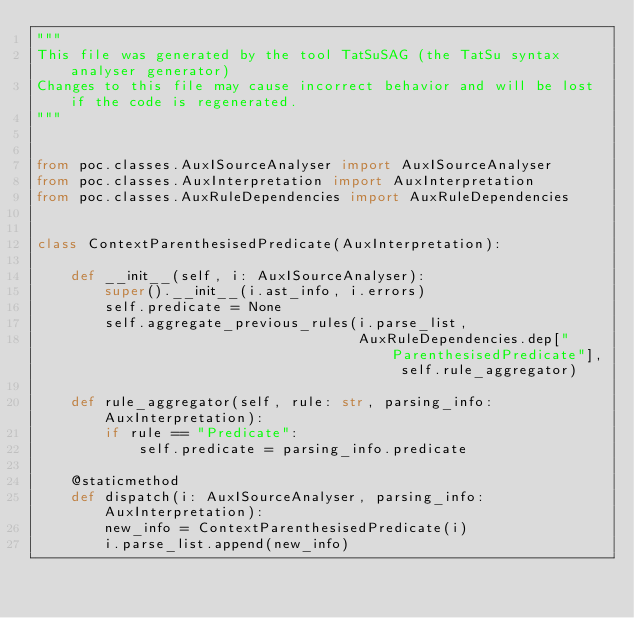Convert code to text. <code><loc_0><loc_0><loc_500><loc_500><_Python_>"""
This file was generated by the tool TatSuSAG (the TatSu syntax analyser generator)
Changes to this file may cause incorrect behavior and will be lost if the code is regenerated.
"""


from poc.classes.AuxISourceAnalyser import AuxISourceAnalyser
from poc.classes.AuxInterpretation import AuxInterpretation
from poc.classes.AuxRuleDependencies import AuxRuleDependencies


class ContextParenthesisedPredicate(AuxInterpretation):

    def __init__(self, i: AuxISourceAnalyser):
        super().__init__(i.ast_info, i.errors)
        self.predicate = None
        self.aggregate_previous_rules(i.parse_list,
                                      AuxRuleDependencies.dep["ParenthesisedPredicate"], self.rule_aggregator)

    def rule_aggregator(self, rule: str, parsing_info: AuxInterpretation):
        if rule == "Predicate":
            self.predicate = parsing_info.predicate

    @staticmethod
    def dispatch(i: AuxISourceAnalyser, parsing_info: AuxInterpretation):
        new_info = ContextParenthesisedPredicate(i)
        i.parse_list.append(new_info)
</code> 